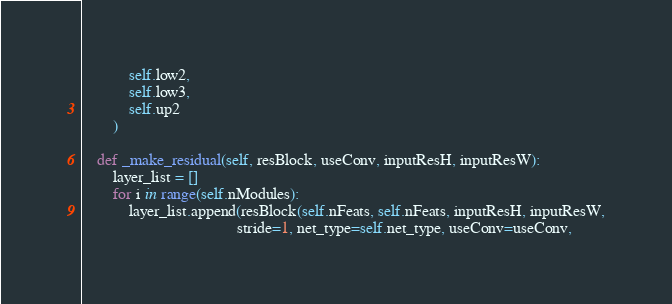Convert code to text. <code><loc_0><loc_0><loc_500><loc_500><_Python_>            self.low2,
            self.low3,
            self.up2
        )

    def _make_residual(self, resBlock, useConv, inputResH, inputResW):
        layer_list = []
        for i in range(self.nModules):
            layer_list.append(resBlock(self.nFeats, self.nFeats, inputResH, inputResW,
                                       stride=1, net_type=self.net_type, useConv=useConv,</code> 